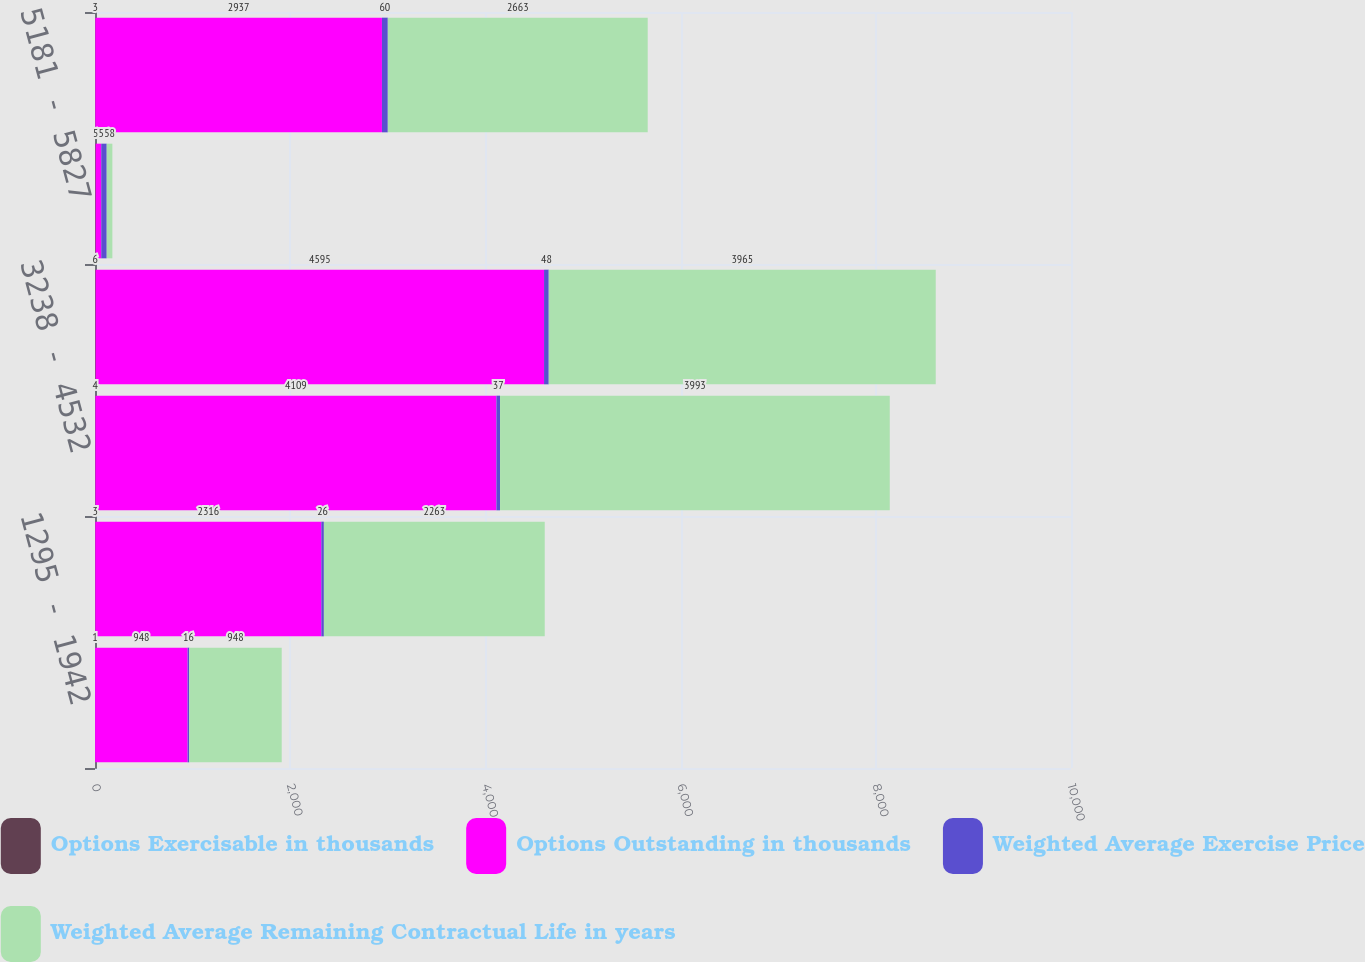<chart> <loc_0><loc_0><loc_500><loc_500><stacked_bar_chart><ecel><fcel>1295 - 1942<fcel>1943 - 3237<fcel>3238 - 4532<fcel>4533 - 5180<fcel>5181 - 5827<fcel>5828 - 6475<nl><fcel>Options Exercisable in thousands<fcel>1<fcel>3<fcel>4<fcel>6<fcel>6<fcel>3<nl><fcel>Options Outstanding in thousands<fcel>948<fcel>2316<fcel>4109<fcel>4595<fcel>58<fcel>2937<nl><fcel>Weighted Average Exercise Price<fcel>16<fcel>26<fcel>37<fcel>48<fcel>56<fcel>60<nl><fcel>Weighted Average Remaining Contractual Life in years<fcel>948<fcel>2263<fcel>3993<fcel>3965<fcel>58<fcel>2663<nl></chart> 